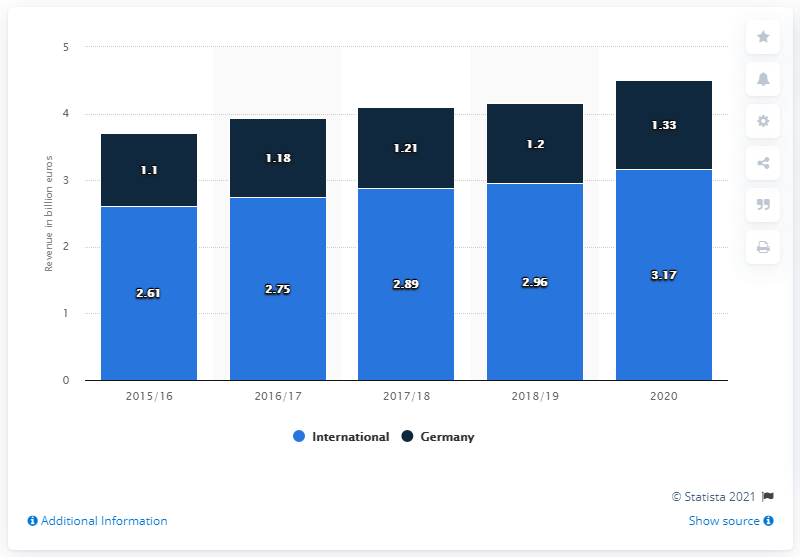Indicate a few pertinent items in this graphic. The year with the least difference between its digits is 2015/16. In the 2020 financial year, Miele generated approximately 1.33 billion euros in revenue in Germany. Miele's home market is located in Germany. 2020 has the highest value among the given years, 